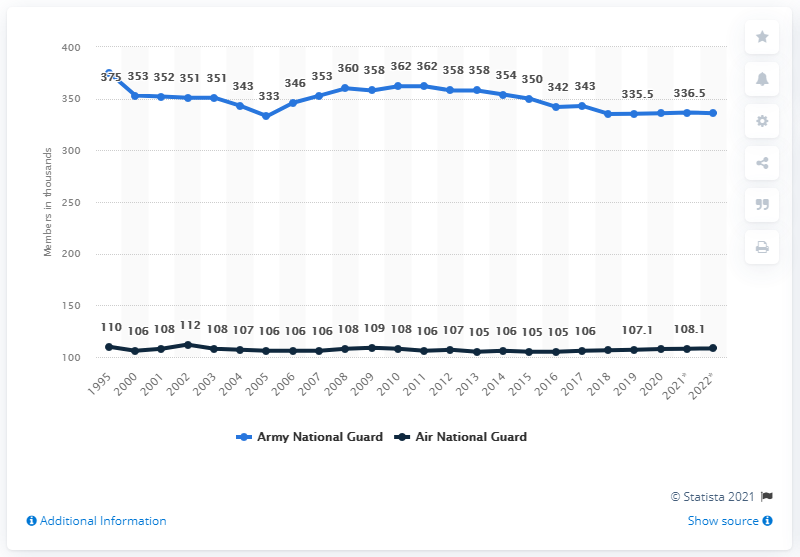Indicate a few pertinent items in this graphic. In the year 2005, the number of Army National Guard in the United States was at its lowest. In 1995, the difference between the Army National Guard and the Air National Guard was the highest. 